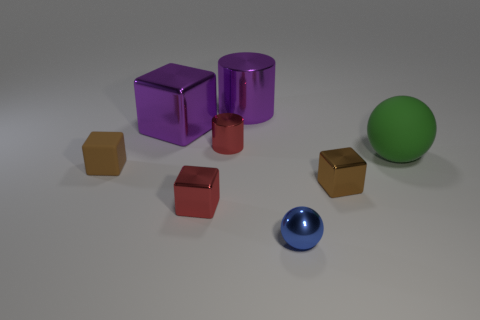Add 2 large matte things. How many objects exist? 10 Subtract all metal cubes. How many cubes are left? 1 Subtract all purple balls. How many brown blocks are left? 2 Subtract all cylinders. How many objects are left? 6 Subtract 1 spheres. How many spheres are left? 1 Subtract all yellow cylinders. Subtract all yellow blocks. How many cylinders are left? 2 Subtract all blue metal balls. Subtract all shiny blocks. How many objects are left? 4 Add 2 tiny blocks. How many tiny blocks are left? 5 Add 4 large green matte spheres. How many large green matte spheres exist? 5 Subtract all red cylinders. How many cylinders are left? 1 